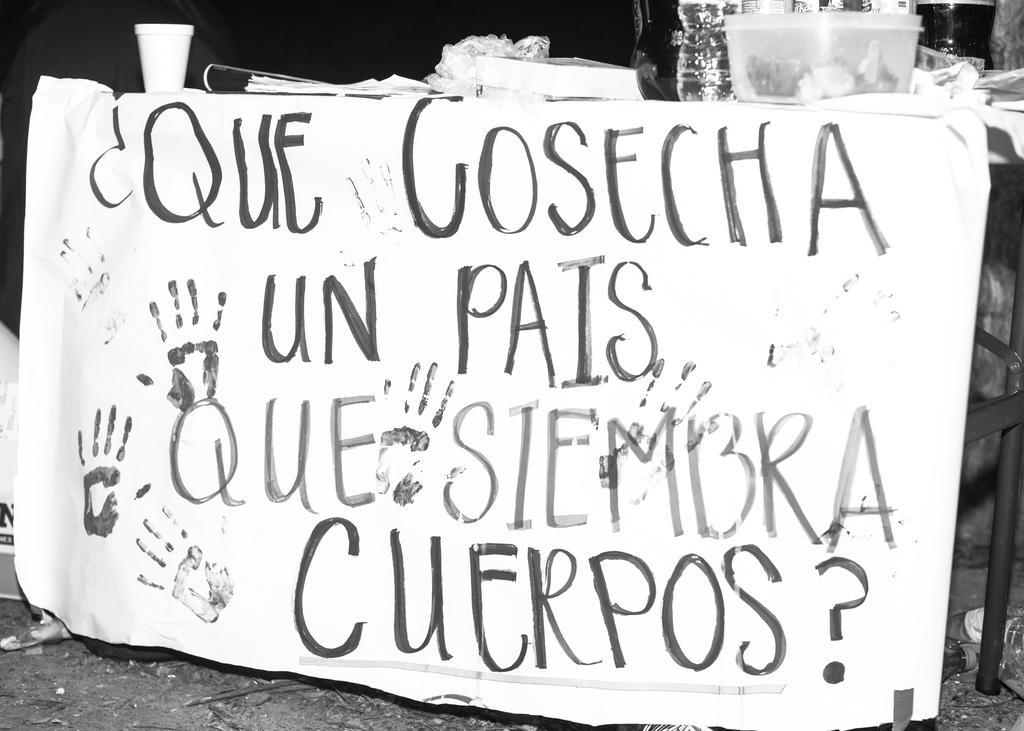Can you describe this image briefly? This is a black and white image where we can see a banner and some text written on it is attached to a table. On the table, there are basket, glasses, cover, book and papers. 